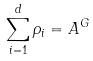Convert formula to latex. <formula><loc_0><loc_0><loc_500><loc_500>\sum _ { i = 1 } ^ { d } \rho _ { i } = { A } ^ { G } \,</formula> 